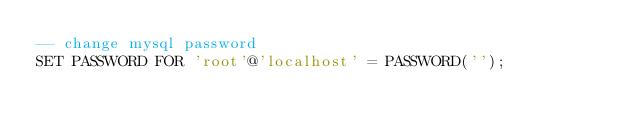Convert code to text. <code><loc_0><loc_0><loc_500><loc_500><_SQL_>-- change mysql password
SET PASSWORD FOR 'root'@'localhost' = PASSWORD('');</code> 